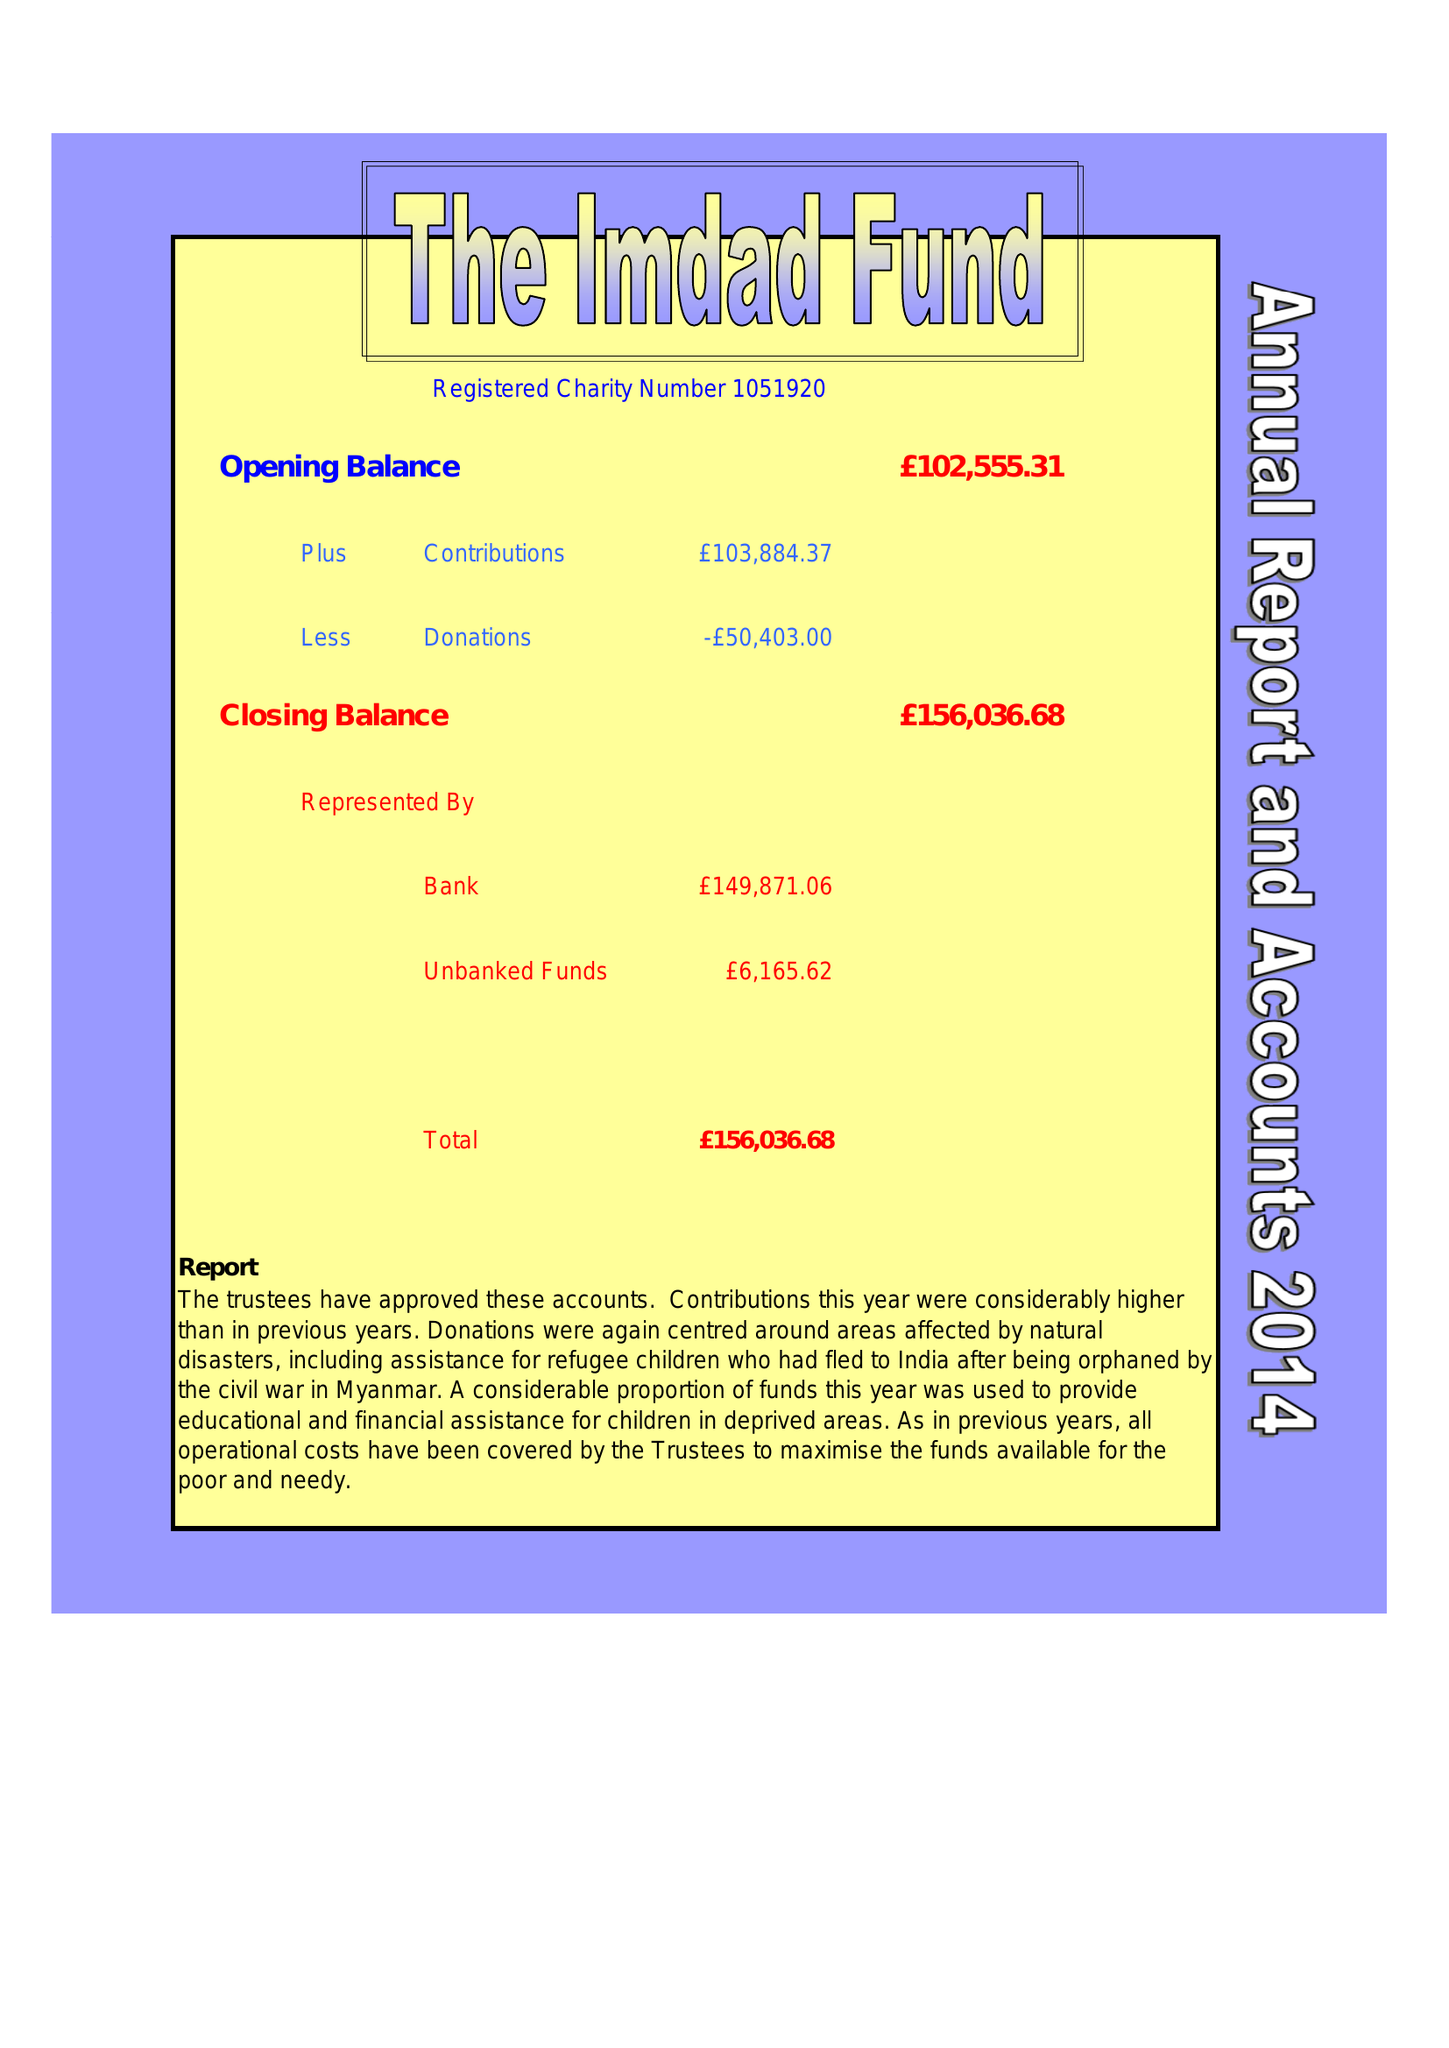What is the value for the address__postcode?
Answer the question using a single word or phrase. E12 6PA 